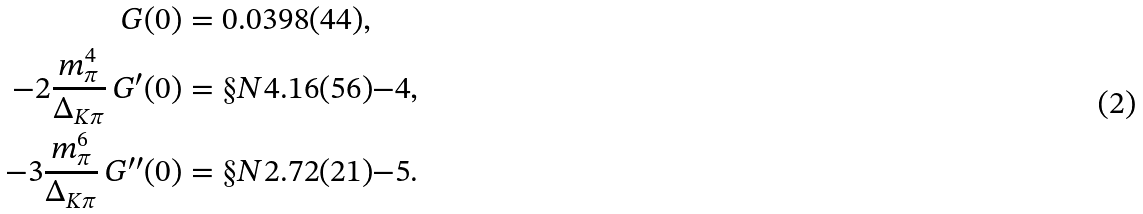<formula> <loc_0><loc_0><loc_500><loc_500>G ( 0 ) & = 0 . 0 3 9 8 ( 4 4 ) , \\ - 2 \frac { m _ { \pi } ^ { 4 } } { \Delta _ { K \pi } } \, G ^ { \prime } ( 0 ) & = \S N { 4 . 1 6 ( 5 6 ) } { - 4 } , \\ - 3 \frac { m _ { \pi } ^ { 6 } } { \Delta _ { K \pi } } \, G ^ { \prime \prime } ( 0 ) & = \S N { 2 . 7 2 ( 2 1 ) } { - 5 } .</formula> 